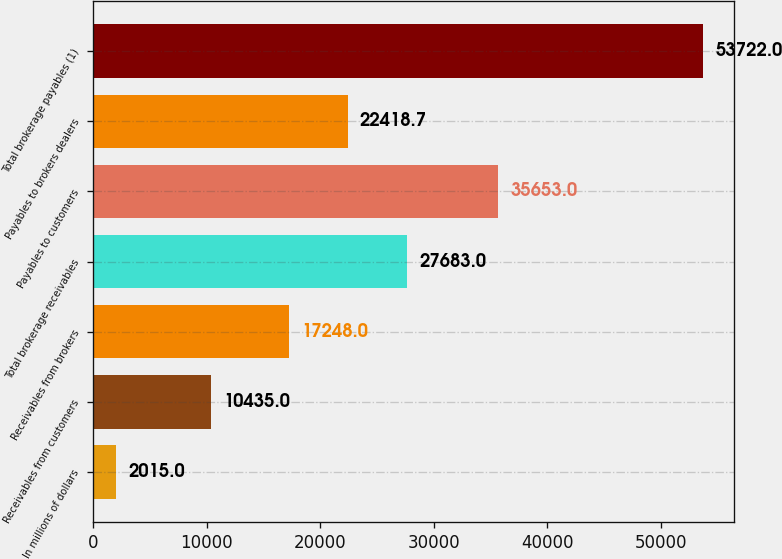Convert chart to OTSL. <chart><loc_0><loc_0><loc_500><loc_500><bar_chart><fcel>In millions of dollars<fcel>Receivables from customers<fcel>Receivables from brokers<fcel>Total brokerage receivables<fcel>Payables to customers<fcel>Payables to brokers dealers<fcel>Total brokerage payables (1)<nl><fcel>2015<fcel>10435<fcel>17248<fcel>27683<fcel>35653<fcel>22418.7<fcel>53722<nl></chart> 